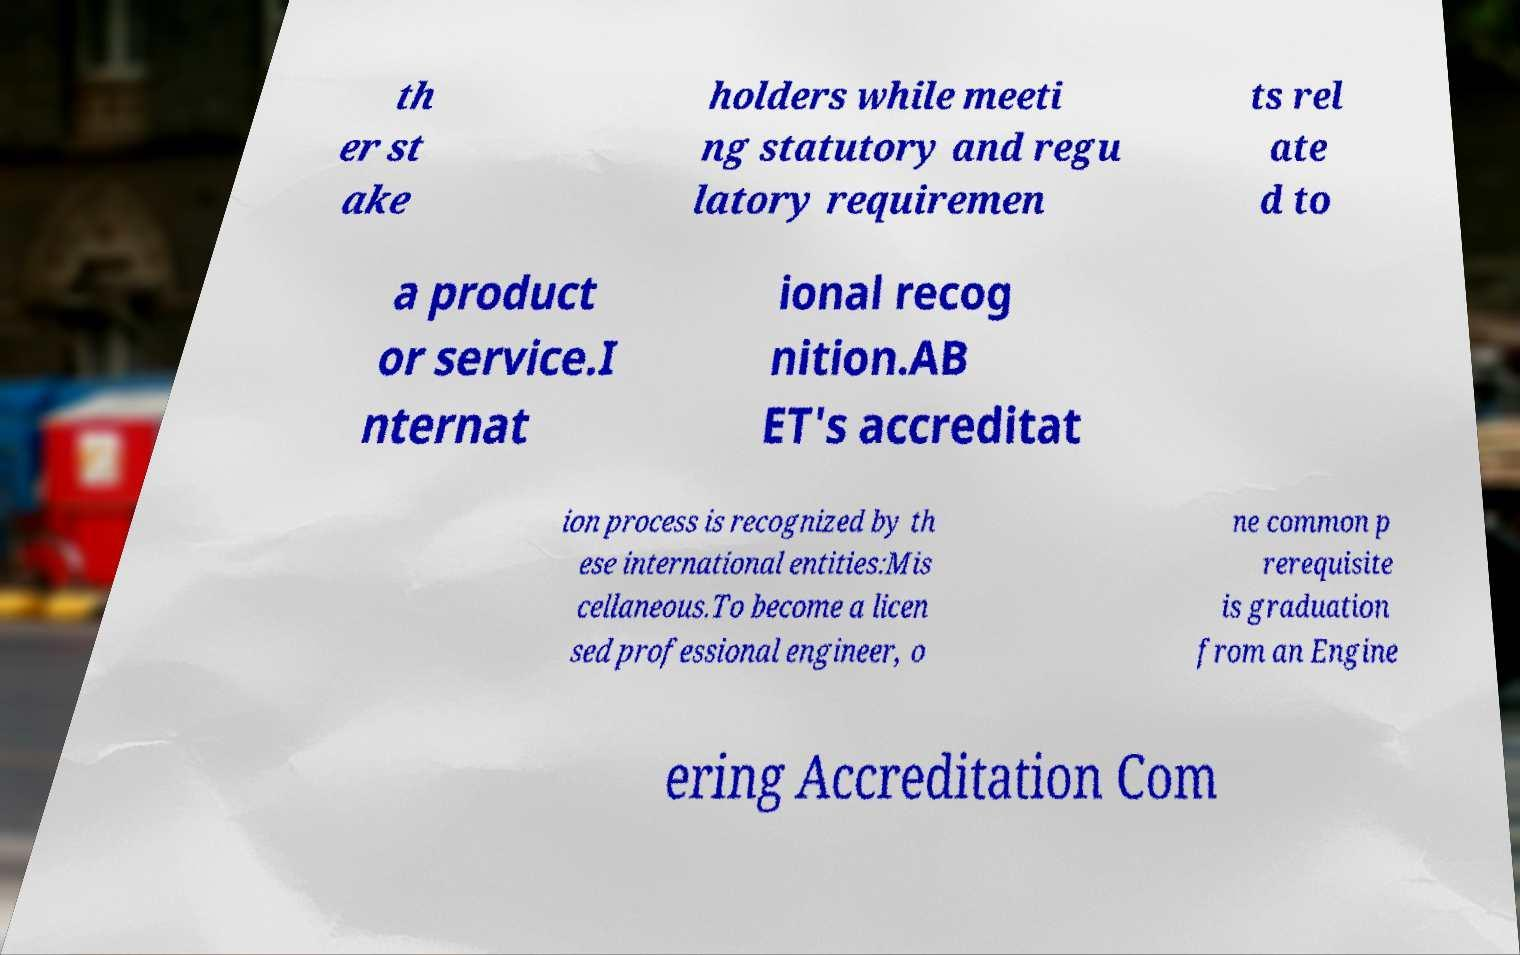Could you assist in decoding the text presented in this image and type it out clearly? th er st ake holders while meeti ng statutory and regu latory requiremen ts rel ate d to a product or service.I nternat ional recog nition.AB ET's accreditat ion process is recognized by th ese international entities:Mis cellaneous.To become a licen sed professional engineer, o ne common p rerequisite is graduation from an Engine ering Accreditation Com 